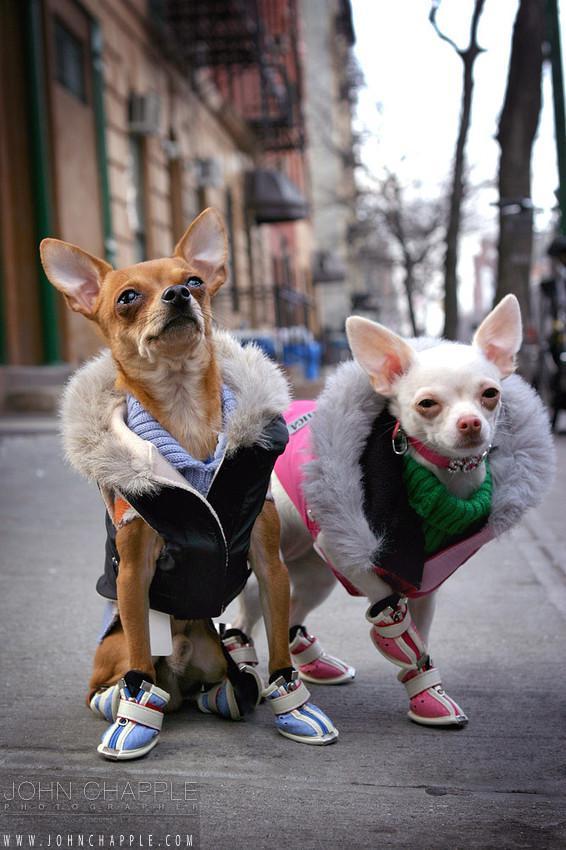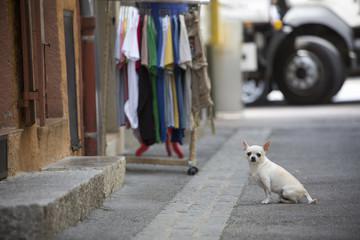The first image is the image on the left, the second image is the image on the right. Given the left and right images, does the statement "Dogs in at least one image are dressed in clothing." hold true? Answer yes or no. Yes. The first image is the image on the left, the second image is the image on the right. Evaluate the accuracy of this statement regarding the images: "There are no more than three dogs". Is it true? Answer yes or no. Yes. 